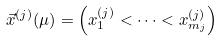Convert formula to latex. <formula><loc_0><loc_0><loc_500><loc_500>\vec { x } ^ { ( j ) } ( \mu ) = \left ( x ^ { ( j ) } _ { 1 } < \cdots < x ^ { ( j ) } _ { m _ { j } } \right )</formula> 